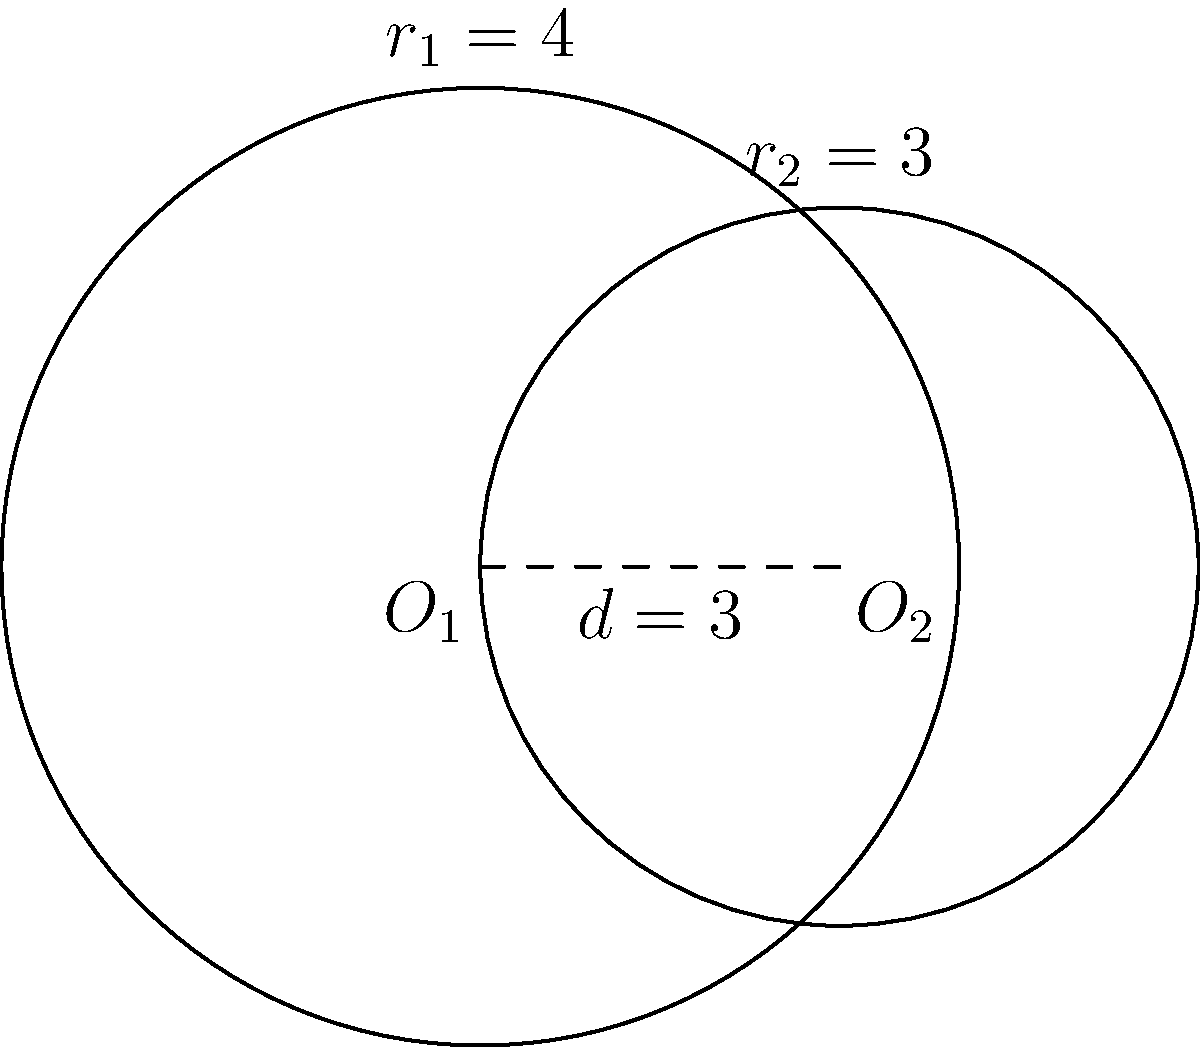As a leader supporting engineering initiatives, you're presented with a problem involving the intersection of two circles. Circle 1 has a radius of 4 units, and Circle 2 has a radius of 3 units. The centers of the circles are 3 units apart. Calculate the area of the overlapping region between these two circles. To solve this problem, we'll use the formula for the area of intersection between two circles:

1) The formula is: 
   $$A = r_1^2 \arccos(\frac{d^2 + r_1^2 - r_2^2}{2dr_1}) + r_2^2 \arccos(\frac{d^2 + r_2^2 - r_1^2}{2dr_2}) - \frac{1}{2}\sqrt{(-d+r_1+r_2)(d+r_1-r_2)(d-r_1+r_2)(d+r_1+r_2)}$$

   Where $r_1$ and $r_2$ are the radii of the circles, and $d$ is the distance between their centers.

2) We have $r_1 = 4$, $r_2 = 3$, and $d = 3$. Let's substitute these values:

3) Calculate the arguments of arccos:
   $$\frac{3^2 + 4^2 - 3^2}{2 \cdot 3 \cdot 4} = \frac{16}{24} = \frac{2}{3}$$
   $$\frac{3^2 + 3^2 - 4^2}{2 \cdot 3 \cdot 3} = \frac{-7}{18}$$

4) Calculate the square root term:
   $$\sqrt{(-3+4+3)(3+4-3)(3-4+3)(3+4+3)} = \sqrt{4 \cdot 4 \cdot 2 \cdot 10} = \sqrt{320} = 8\sqrt{5}$$

5) Now we can write out our equation:
   $$A = 16 \arccos(\frac{2}{3}) + 9 \arccos(-\frac{7}{18}) - \frac{1}{2} \cdot 8\sqrt{5}$$

6) Using a calculator or computer:
   $$A \approx 16 \cdot 0.8411 + 9 \cdot 2.2009 - 4\sqrt{5} \approx 13.4576 + 19.8081 - 8.9443 \approx 24.3214$$

Therefore, the area of overlap is approximately 24.3214 square units.
Answer: 24.3214 square units 